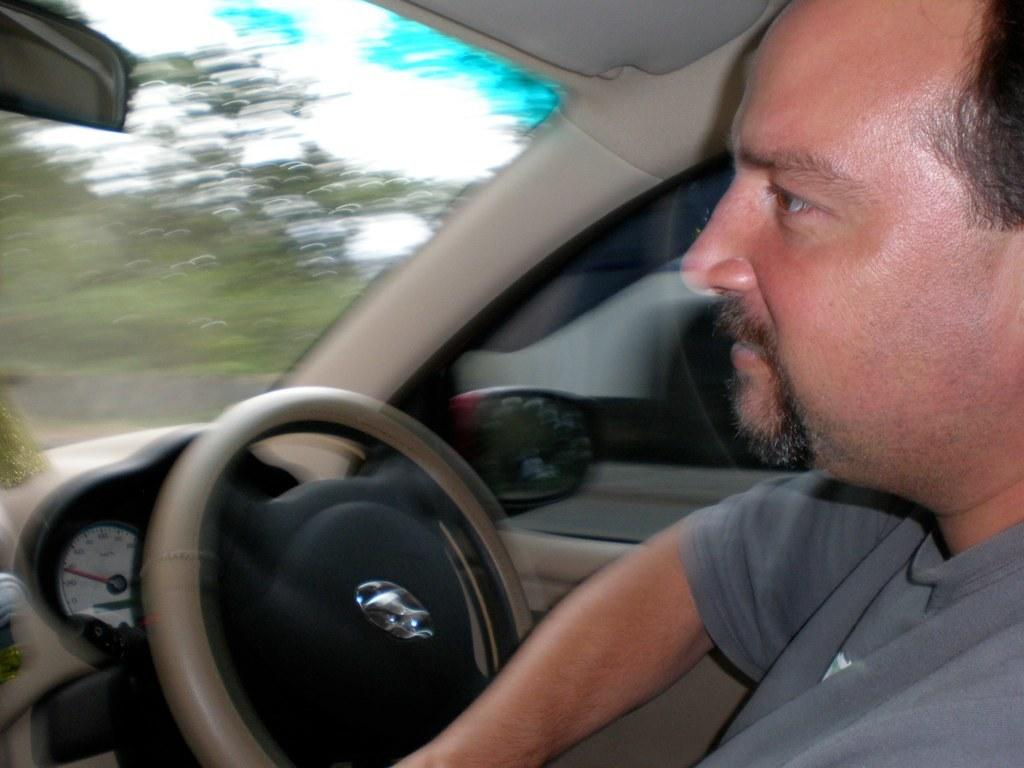Who is present in the image? There is a man in the image. What is the man doing in the image? The man is sitting in a car. What type of hand can be seen holding a worm in the image? There is no hand or worm present in the image; it features a man sitting in a car. 